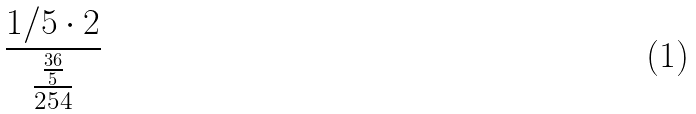<formula> <loc_0><loc_0><loc_500><loc_500>\frac { 1 / 5 \cdot 2 } { \frac { \frac { 3 6 } { 5 } } { 2 5 4 } }</formula> 